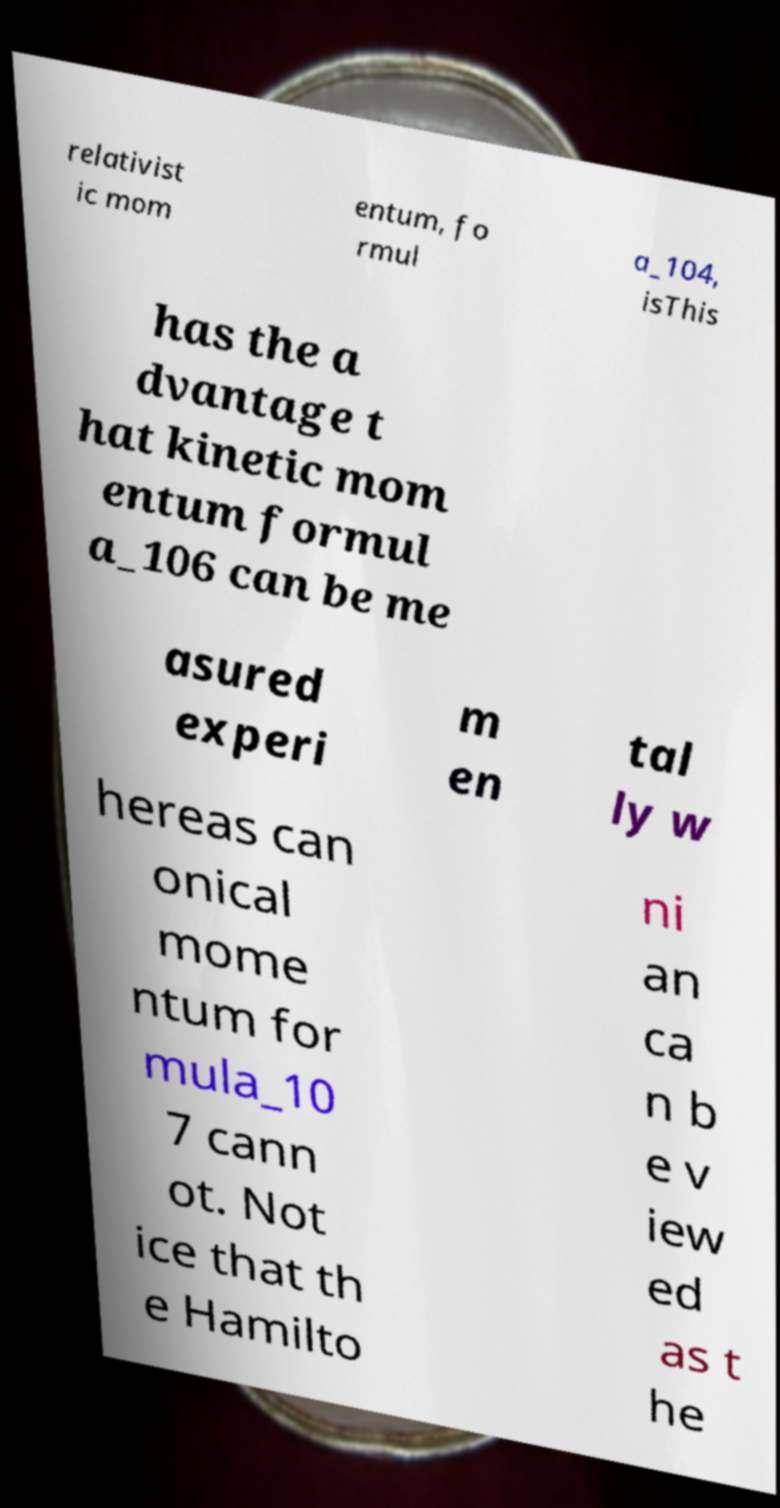Could you assist in decoding the text presented in this image and type it out clearly? relativist ic mom entum, fo rmul a_104, isThis has the a dvantage t hat kinetic mom entum formul a_106 can be me asured experi m en tal ly w hereas can onical mome ntum for mula_10 7 cann ot. Not ice that th e Hamilto ni an ca n b e v iew ed as t he 